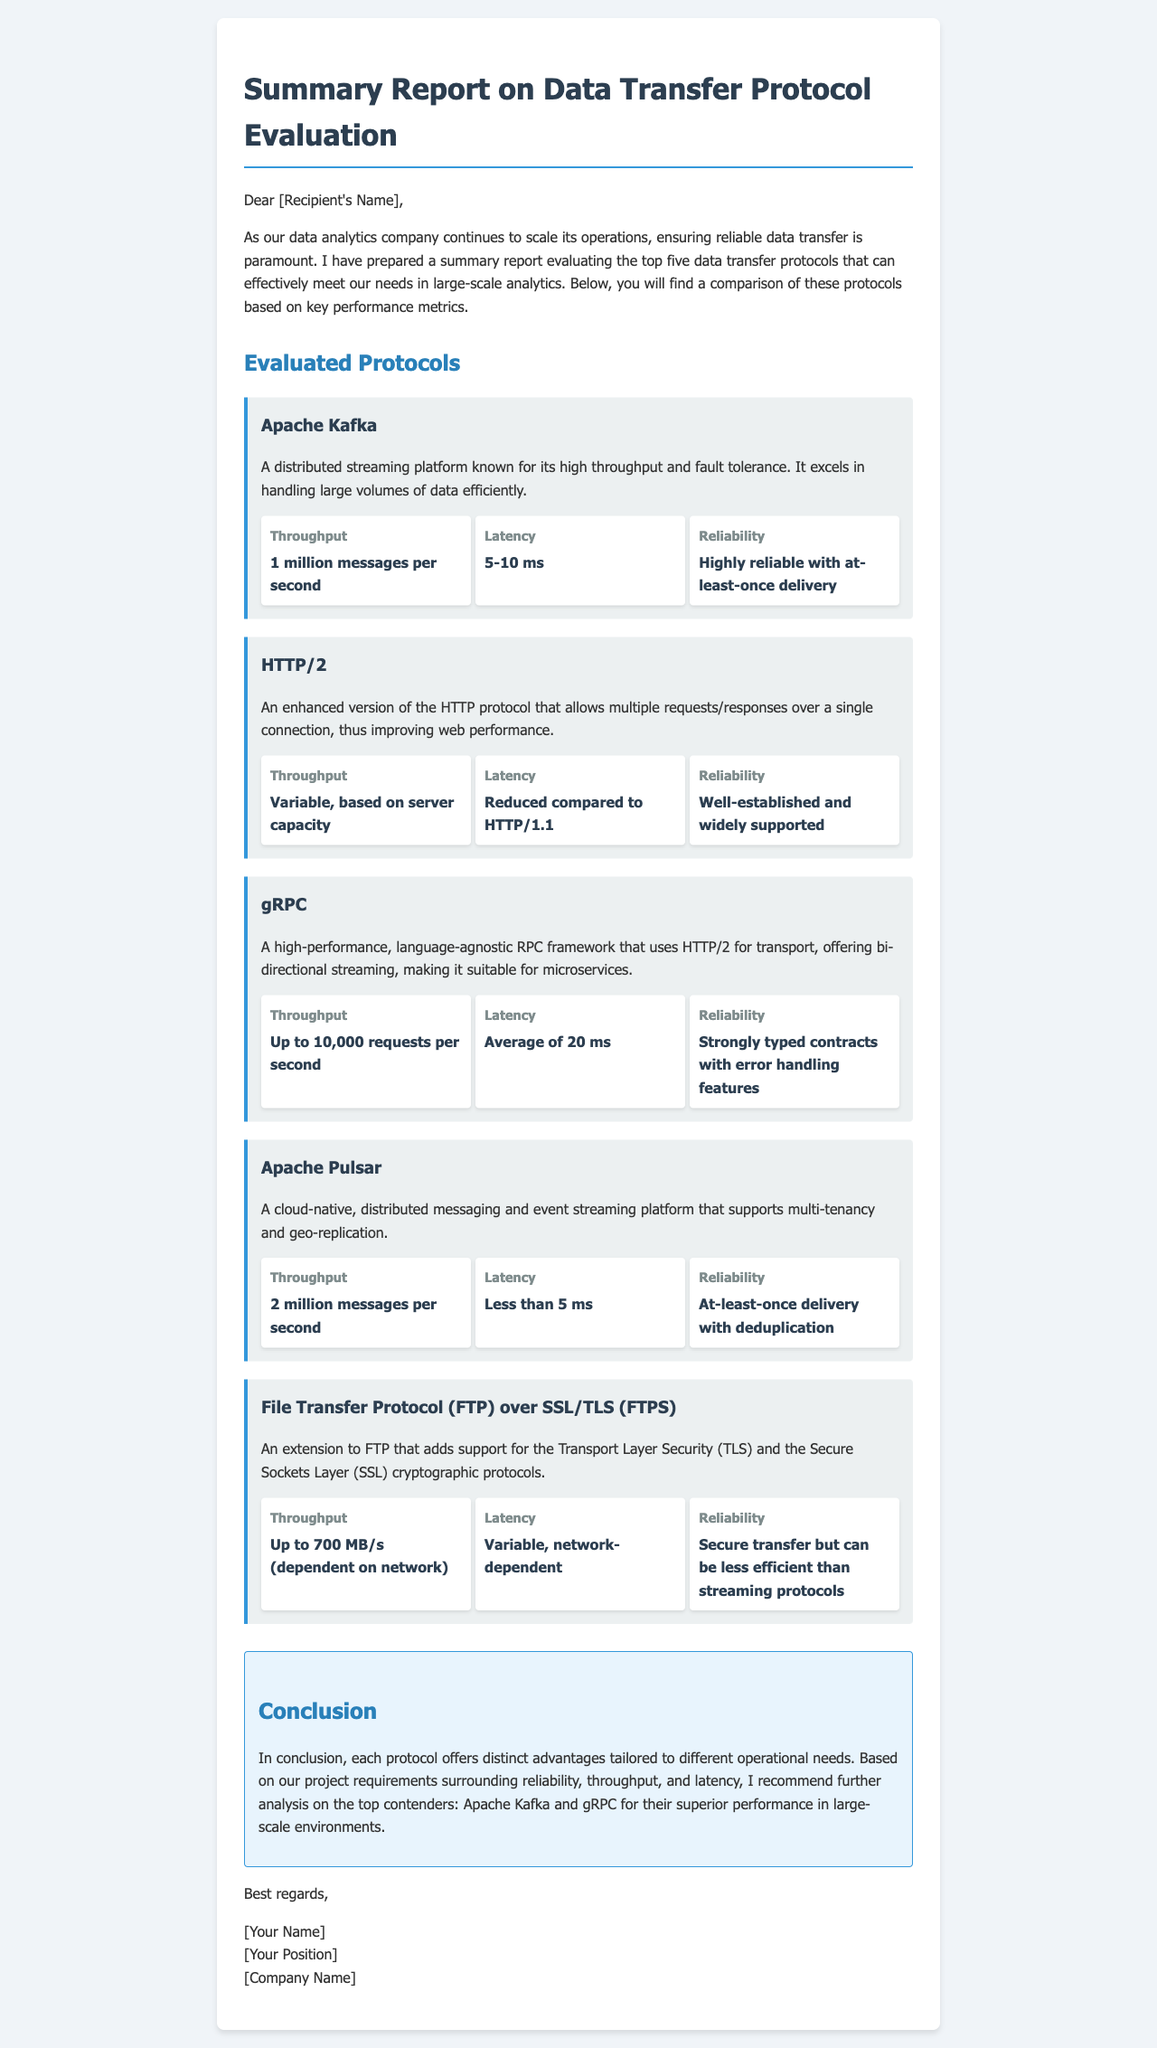What are the top five data transfer protocols evaluated? The document lists Apache Kafka, HTTP/2, gRPC, Apache Pulsar, and FTPS as the top five data transfer protocols evaluated.
Answer: Apache Kafka, HTTP/2, gRPC, Apache Pulsar, FTPS What is the throughput of Apache Pulsar? The document states that Apache Pulsar has a throughput of 2 million messages per second.
Answer: 2 million messages per second What is the latency of gRPC? According to the document, the average latency of gRPC is 20 ms.
Answer: 20 ms Which protocol has the highest throughput? The document specifies that Apache Kafka has the highest throughput with 1 million messages per second.
Answer: Apache Kafka What are the reliability characteristics of FTP over SSL/TLS? The document describes the reliability of FTPS as secure transfer but can be less efficient than streaming protocols.
Answer: Secure transfer but can be less efficient than streaming protocols Which two protocols are recommended for further analysis? The document recommends Apache Kafka and gRPC for further analysis based on their performance.
Answer: Apache Kafka and gRPC What is the conclusion of the report? The conclusion emphasizes the distinct advantages of each protocol and recommends further analysis on Apache Kafka and gRPC.
Answer: Each protocol offers distinct advantages tailored to different operational needs What is the average throughput for gRPC? The document states that gRPC can handle up to 10,000 requests per second.
Answer: Up to 10,000 requests per second 